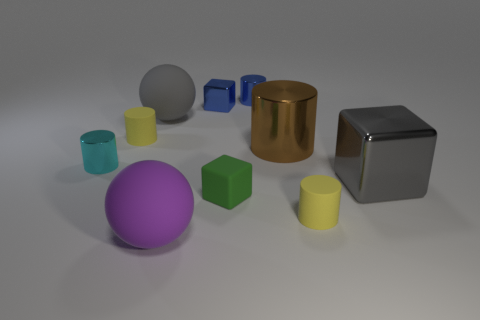Does the big purple thing have the same shape as the large gray rubber thing?
Offer a very short reply. Yes. There is a blue object that is the same shape as the big brown metal object; what size is it?
Offer a very short reply. Small. What number of small blue blocks have the same material as the blue cylinder?
Your response must be concise. 1. What number of objects are either tiny gray matte things or yellow matte objects?
Keep it short and to the point. 2. There is a cube behind the big gray ball; is there a yellow matte thing that is right of it?
Your answer should be very brief. Yes. Is the number of yellow objects that are to the left of the tiny green cube greater than the number of matte things that are behind the small blue cylinder?
Give a very brief answer. Yes. What material is the tiny thing that is the same color as the tiny metal cube?
Your answer should be compact. Metal. What number of things are the same color as the large block?
Make the answer very short. 1. There is a metal cube left of the small blue shiny cylinder; is it the same color as the tiny shiny cylinder that is to the right of the cyan object?
Your answer should be compact. Yes. Are there any brown metallic cylinders in front of the gray metallic block?
Your answer should be very brief. No. 